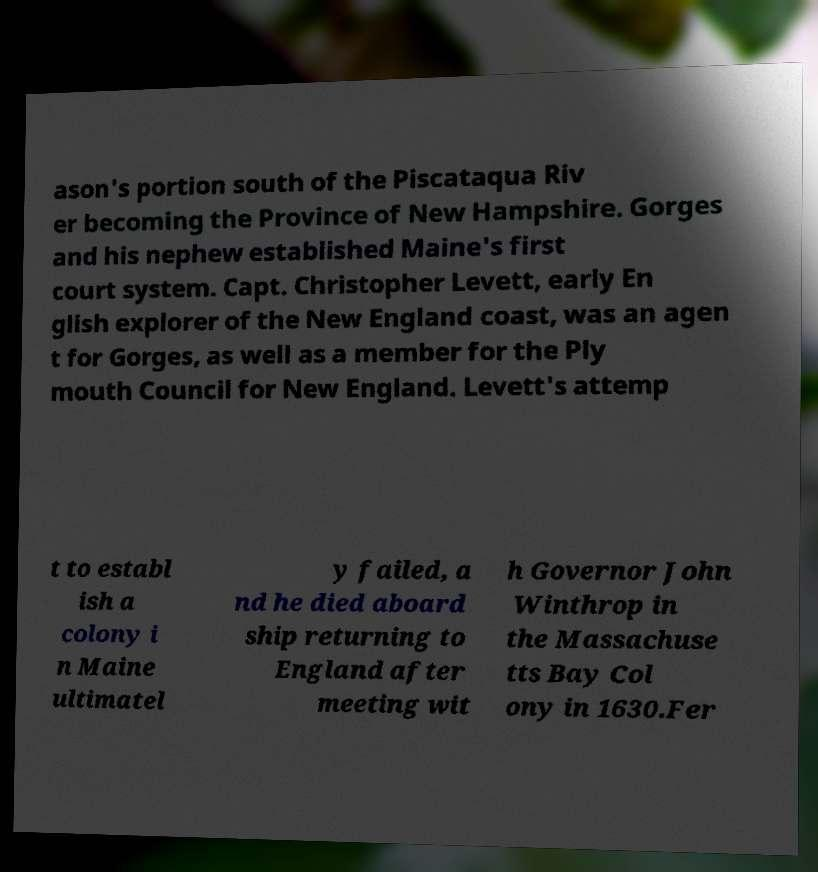Please read and relay the text visible in this image. What does it say? ason's portion south of the Piscataqua Riv er becoming the Province of New Hampshire. Gorges and his nephew established Maine's first court system. Capt. Christopher Levett, early En glish explorer of the New England coast, was an agen t for Gorges, as well as a member for the Ply mouth Council for New England. Levett's attemp t to establ ish a colony i n Maine ultimatel y failed, a nd he died aboard ship returning to England after meeting wit h Governor John Winthrop in the Massachuse tts Bay Col ony in 1630.Fer 